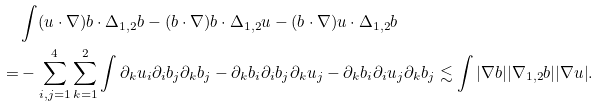<formula> <loc_0><loc_0><loc_500><loc_500>& \int ( u \cdot \nabla ) b \cdot \Delta _ { 1 , 2 } b - ( b \cdot \nabla ) b \cdot \Delta _ { 1 , 2 } u - ( b \cdot \nabla ) u \cdot \Delta _ { 1 , 2 } b \\ = & - \sum _ { i , j = 1 } ^ { 4 } \sum _ { k = 1 } ^ { 2 } \int \partial _ { k } u _ { i } \partial _ { i } b _ { j } \partial _ { k } b _ { j } - \partial _ { k } b _ { i } \partial _ { i } b _ { j } \partial _ { k } u _ { j } - \partial _ { k } b _ { i } \partial _ { i } u _ { j } \partial _ { k } b _ { j } \lesssim \int | \nabla b | | \nabla _ { 1 , 2 } b | | \nabla u | .</formula> 